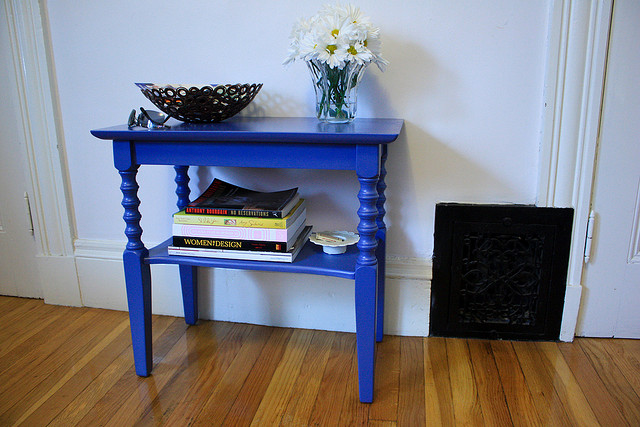Identify and read out the text in this image. WOMEN|DESIGN 